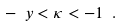<formula> <loc_0><loc_0><loc_500><loc_500>- \ y < \kappa < - 1 \ .</formula> 